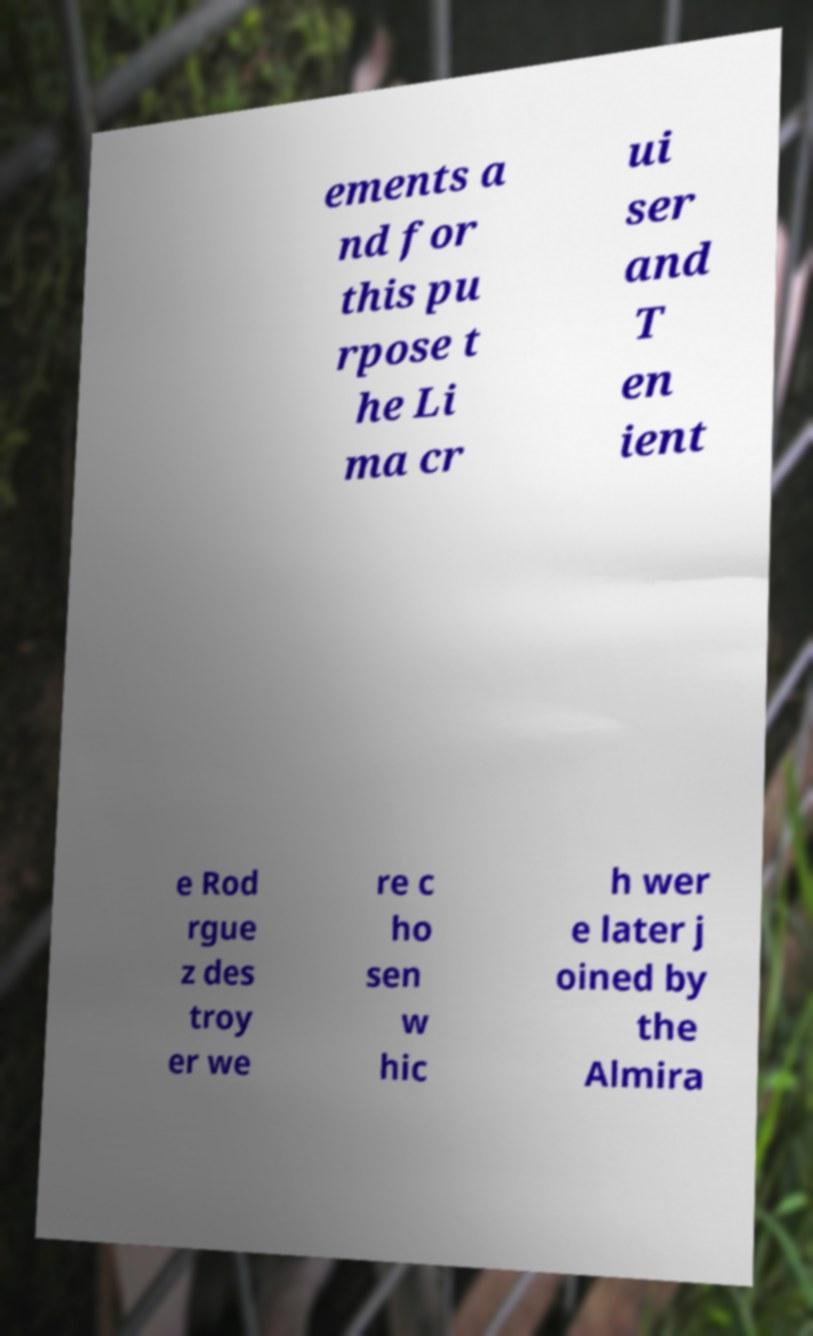Please read and relay the text visible in this image. What does it say? ements a nd for this pu rpose t he Li ma cr ui ser and T en ient e Rod rgue z des troy er we re c ho sen w hic h wer e later j oined by the Almira 